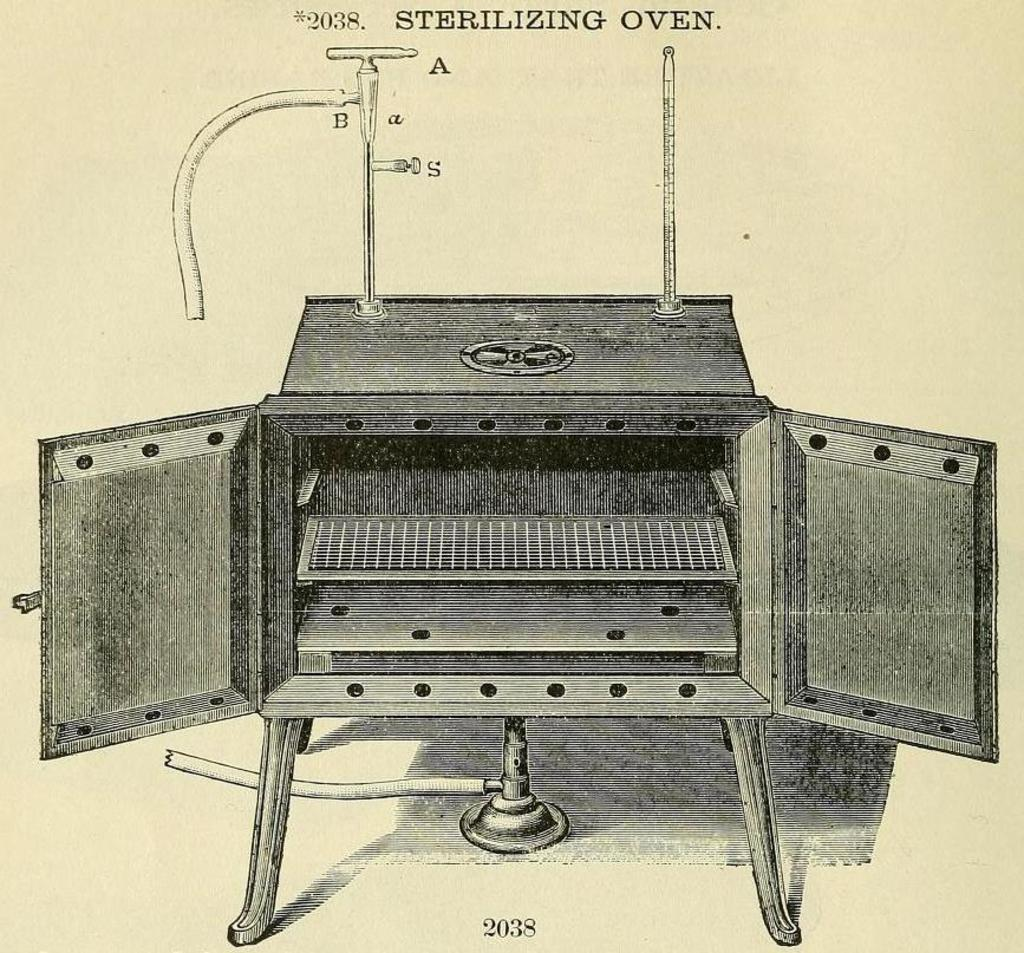What type of equipment is shown in the image? There is a sterilizing oven in the image. What can be seen at the top of the image? There is text at the top of the image. What can be seen at the bottom of the image? There is text at the bottom of the image. How many cars are visible in the image? There are no cars present in the image. What type of breath does the sterilizing oven have in the image? The sterilizing oven does not have a breath, as it is an inanimate object. 